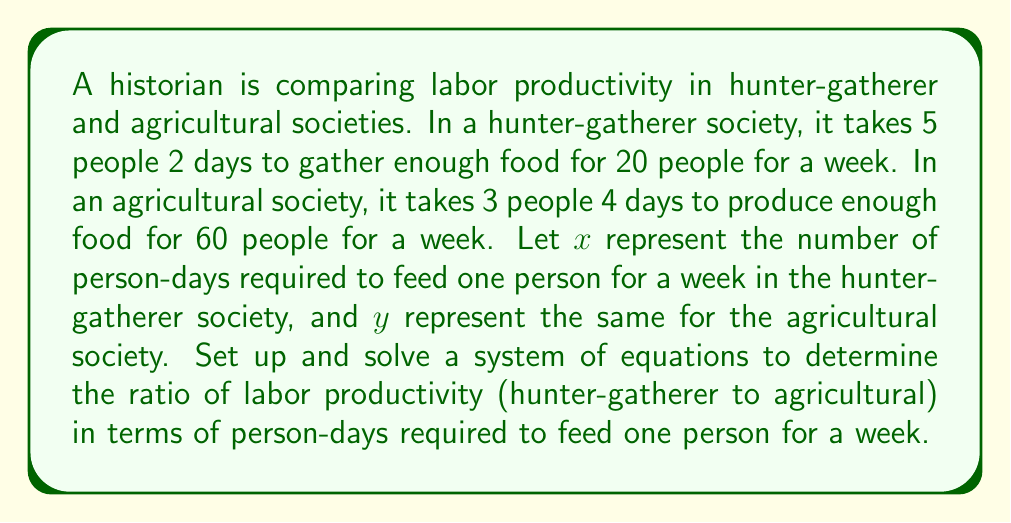Could you help me with this problem? 1. Set up equations for each society:
   Hunter-gatherer: $\frac{5 \cdot 2}{20} = x$
   Agricultural: $\frac{3 \cdot 4}{60} = y$

2. Simplify the equations:
   $x = \frac{1}{2}$
   $y = \frac{1}{5}$

3. To find the ratio of labor productivity, we divide $x$ by $y$:
   $$\frac{x}{y} = \frac{\frac{1}{2}}{\frac{1}{5}} = \frac{1}{2} \cdot \frac{5}{1} = \frac{5}{2} = 2.5$$

4. This ratio means that the hunter-gatherer society requires 2.5 times more person-days to feed one person for a week compared to the agricultural society.

5. To express this as a ratio, we can write it as 5:2 (hunter-gatherer : agricultural).
Answer: 5:2 